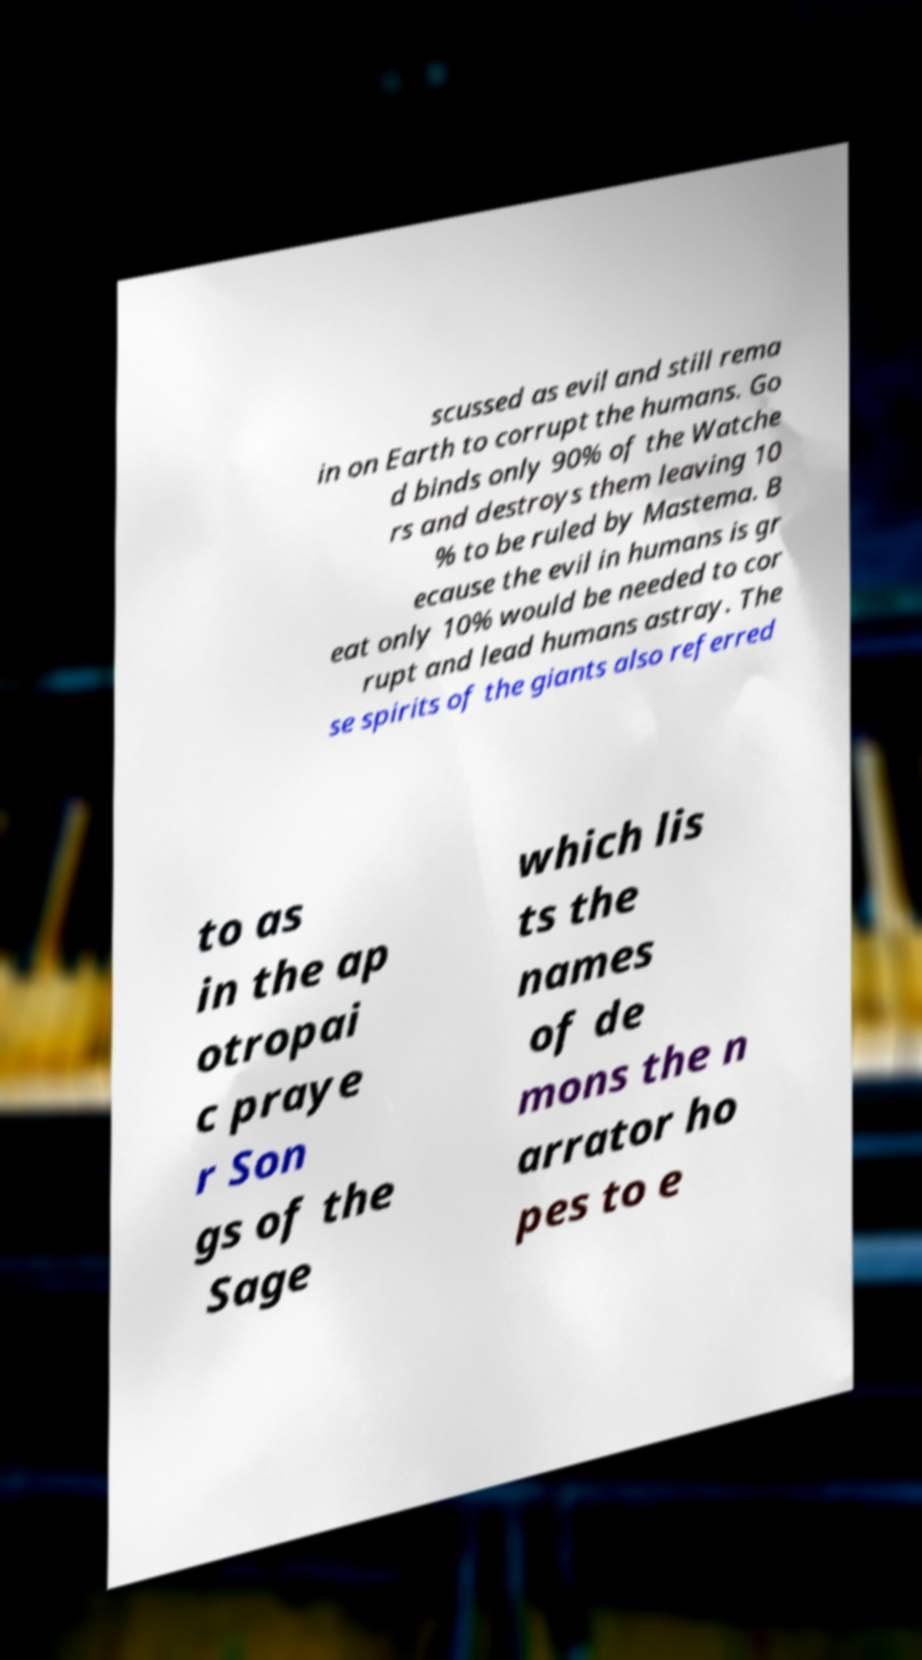Could you assist in decoding the text presented in this image and type it out clearly? scussed as evil and still rema in on Earth to corrupt the humans. Go d binds only 90% of the Watche rs and destroys them leaving 10 % to be ruled by Mastema. B ecause the evil in humans is gr eat only 10% would be needed to cor rupt and lead humans astray. The se spirits of the giants also referred to as in the ap otropai c praye r Son gs of the Sage which lis ts the names of de mons the n arrator ho pes to e 